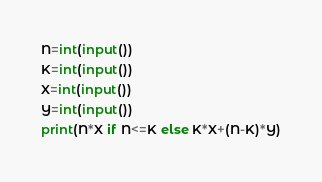Convert code to text. <code><loc_0><loc_0><loc_500><loc_500><_Python_>N=int(input())
K=int(input())
X=int(input())
Y=int(input())
print(N*X if N<=K else K*X+(N-K)*Y)
</code> 